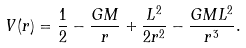<formula> <loc_0><loc_0><loc_500><loc_500>V ( r ) = \frac { 1 } { 2 } - \frac { G M } { r } + \frac { L ^ { 2 } } { 2 r ^ { 2 } } - \frac { G M L ^ { 2 } } { r ^ { 3 } } .</formula> 